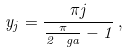Convert formula to latex. <formula><loc_0><loc_0><loc_500><loc_500>y _ { j } = \frac { \pi j } { \frac { \pi } { 2 \ g a } - 1 } \, ,</formula> 